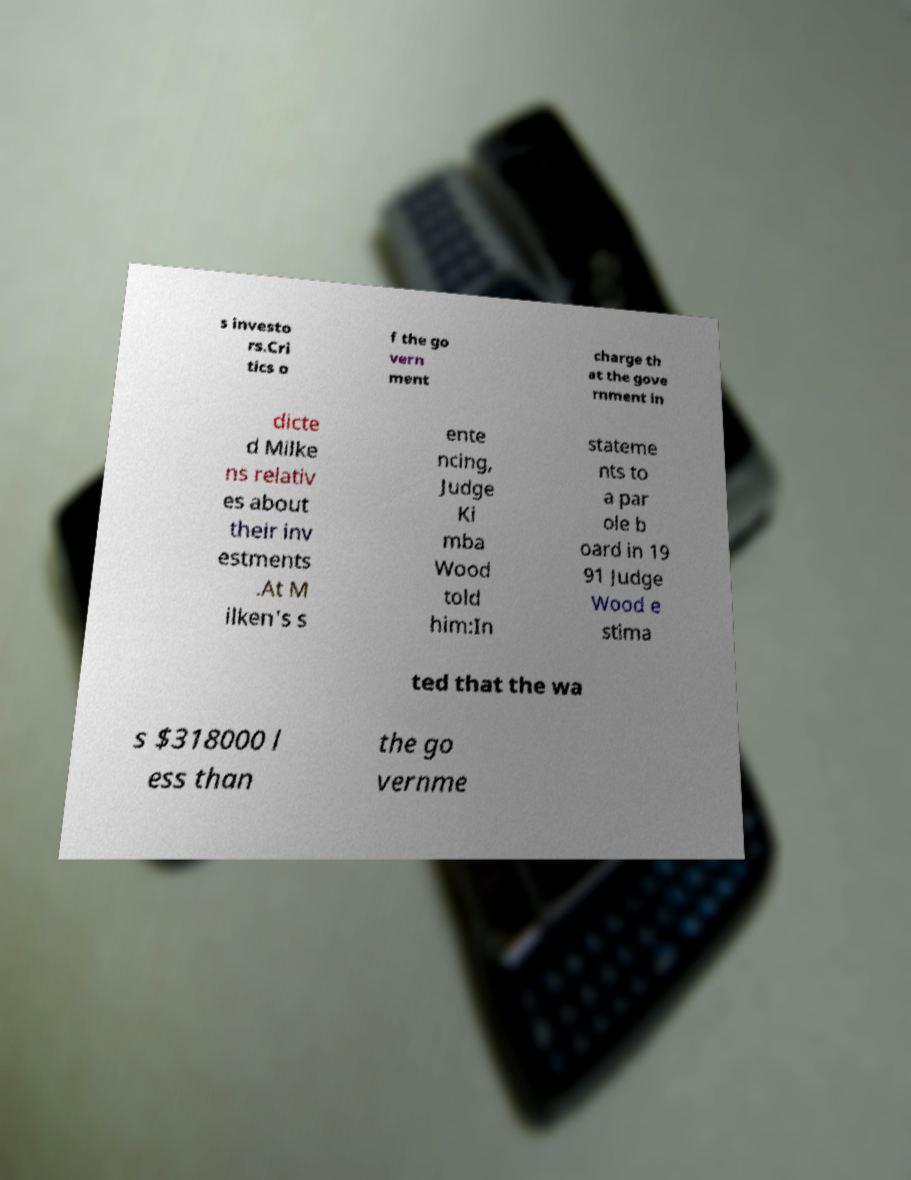There's text embedded in this image that I need extracted. Can you transcribe it verbatim? s investo rs.Cri tics o f the go vern ment charge th at the gove rnment in dicte d Milke ns relativ es about their inv estments .At M ilken's s ente ncing, Judge Ki mba Wood told him:In stateme nts to a par ole b oard in 19 91 Judge Wood e stima ted that the wa s $318000 l ess than the go vernme 